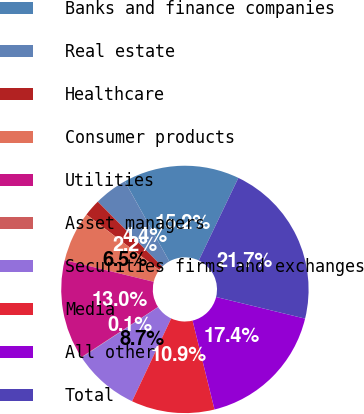Convert chart to OTSL. <chart><loc_0><loc_0><loc_500><loc_500><pie_chart><fcel>Banks and finance companies<fcel>Real estate<fcel>Healthcare<fcel>Consumer products<fcel>Utilities<fcel>Asset managers<fcel>Securities firms and exchanges<fcel>Media<fcel>All other<fcel>Total<nl><fcel>15.19%<fcel>4.37%<fcel>2.21%<fcel>6.54%<fcel>13.03%<fcel>0.05%<fcel>8.7%<fcel>10.87%<fcel>17.36%<fcel>21.68%<nl></chart> 